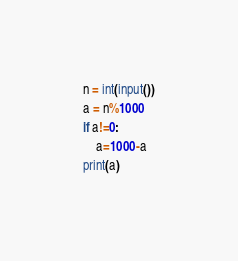<code> <loc_0><loc_0><loc_500><loc_500><_Python_>n = int(input())
a = n%1000
if a!=0:
    a=1000-a
print(a)
</code> 